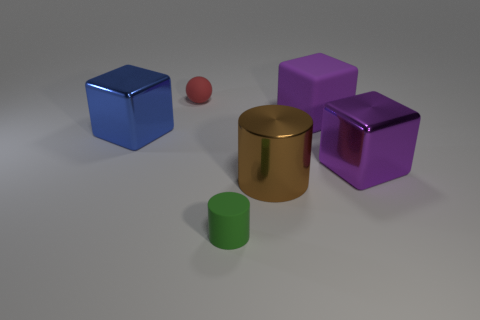Besides the cylindrical objects, are there any other items that stand out due to their unique shape or color? Aside from the cylindrical items, the small red rubber ball is notable for its distinct spherical shape and bright color, which contrasts with the angular shapes and more subdued hues of the other objects. 